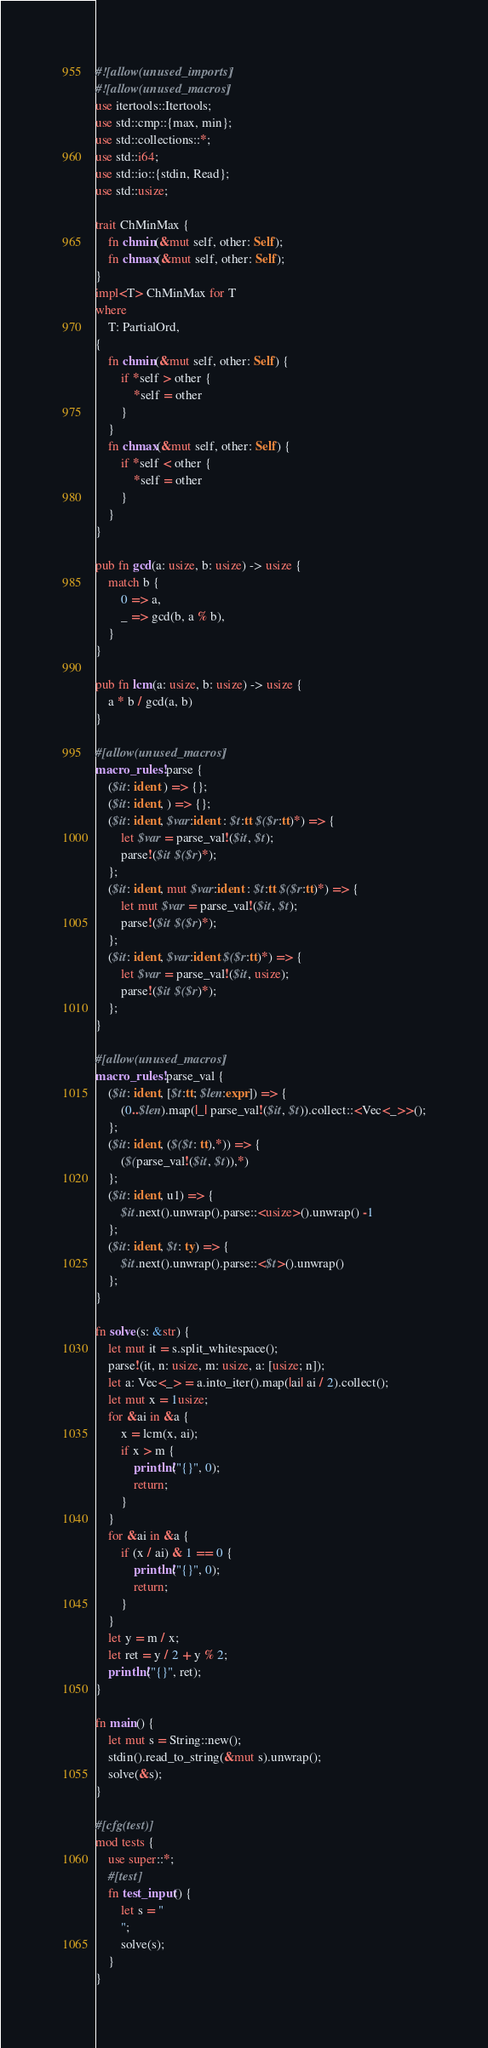Convert code to text. <code><loc_0><loc_0><loc_500><loc_500><_Rust_>#![allow(unused_imports)]
#![allow(unused_macros)]
use itertools::Itertools;
use std::cmp::{max, min};
use std::collections::*;
use std::i64;
use std::io::{stdin, Read};
use std::usize;

trait ChMinMax {
    fn chmin(&mut self, other: Self);
    fn chmax(&mut self, other: Self);
}
impl<T> ChMinMax for T
where
    T: PartialOrd,
{
    fn chmin(&mut self, other: Self) {
        if *self > other {
            *self = other
        }
    }
    fn chmax(&mut self, other: Self) {
        if *self < other {
            *self = other
        }
    }
}

pub fn gcd(a: usize, b: usize) -> usize {
    match b {
        0 => a,
        _ => gcd(b, a % b),
    }
}

pub fn lcm(a: usize, b: usize) -> usize {
    a * b / gcd(a, b)
}

#[allow(unused_macros)]
macro_rules! parse {
    ($it: ident ) => {};
    ($it: ident, ) => {};
    ($it: ident, $var:ident : $t:tt $($r:tt)*) => {
        let $var = parse_val!($it, $t);
        parse!($it $($r)*);
    };
    ($it: ident, mut $var:ident : $t:tt $($r:tt)*) => {
        let mut $var = parse_val!($it, $t);
        parse!($it $($r)*);
    };
    ($it: ident, $var:ident $($r:tt)*) => {
        let $var = parse_val!($it, usize);
        parse!($it $($r)*);
    };
}

#[allow(unused_macros)]
macro_rules! parse_val {
    ($it: ident, [$t:tt; $len:expr]) => {
        (0..$len).map(|_| parse_val!($it, $t)).collect::<Vec<_>>();
    };
    ($it: ident, ($($t: tt),*)) => {
        ($(parse_val!($it, $t)),*)
    };
    ($it: ident, u1) => {
        $it.next().unwrap().parse::<usize>().unwrap() -1
    };
    ($it: ident, $t: ty) => {
        $it.next().unwrap().parse::<$t>().unwrap()
    };
}

fn solve(s: &str) {
    let mut it = s.split_whitespace();
    parse!(it, n: usize, m: usize, a: [usize; n]);
    let a: Vec<_> = a.into_iter().map(|ai| ai / 2).collect();
    let mut x = 1usize;
    for &ai in &a {
        x = lcm(x, ai);
        if x > m {
            println!("{}", 0);
            return;
        }
    }
    for &ai in &a {
        if (x / ai) & 1 == 0 {
            println!("{}", 0);
            return;
        }
    }
    let y = m / x;
    let ret = y / 2 + y % 2;
    println!("{}", ret);
}

fn main() {
    let mut s = String::new();
    stdin().read_to_string(&mut s).unwrap();
    solve(&s);
}

#[cfg(test)]
mod tests {
    use super::*;
    #[test]
    fn test_input() {
        let s = "
        ";
        solve(s);
    }
}
</code> 